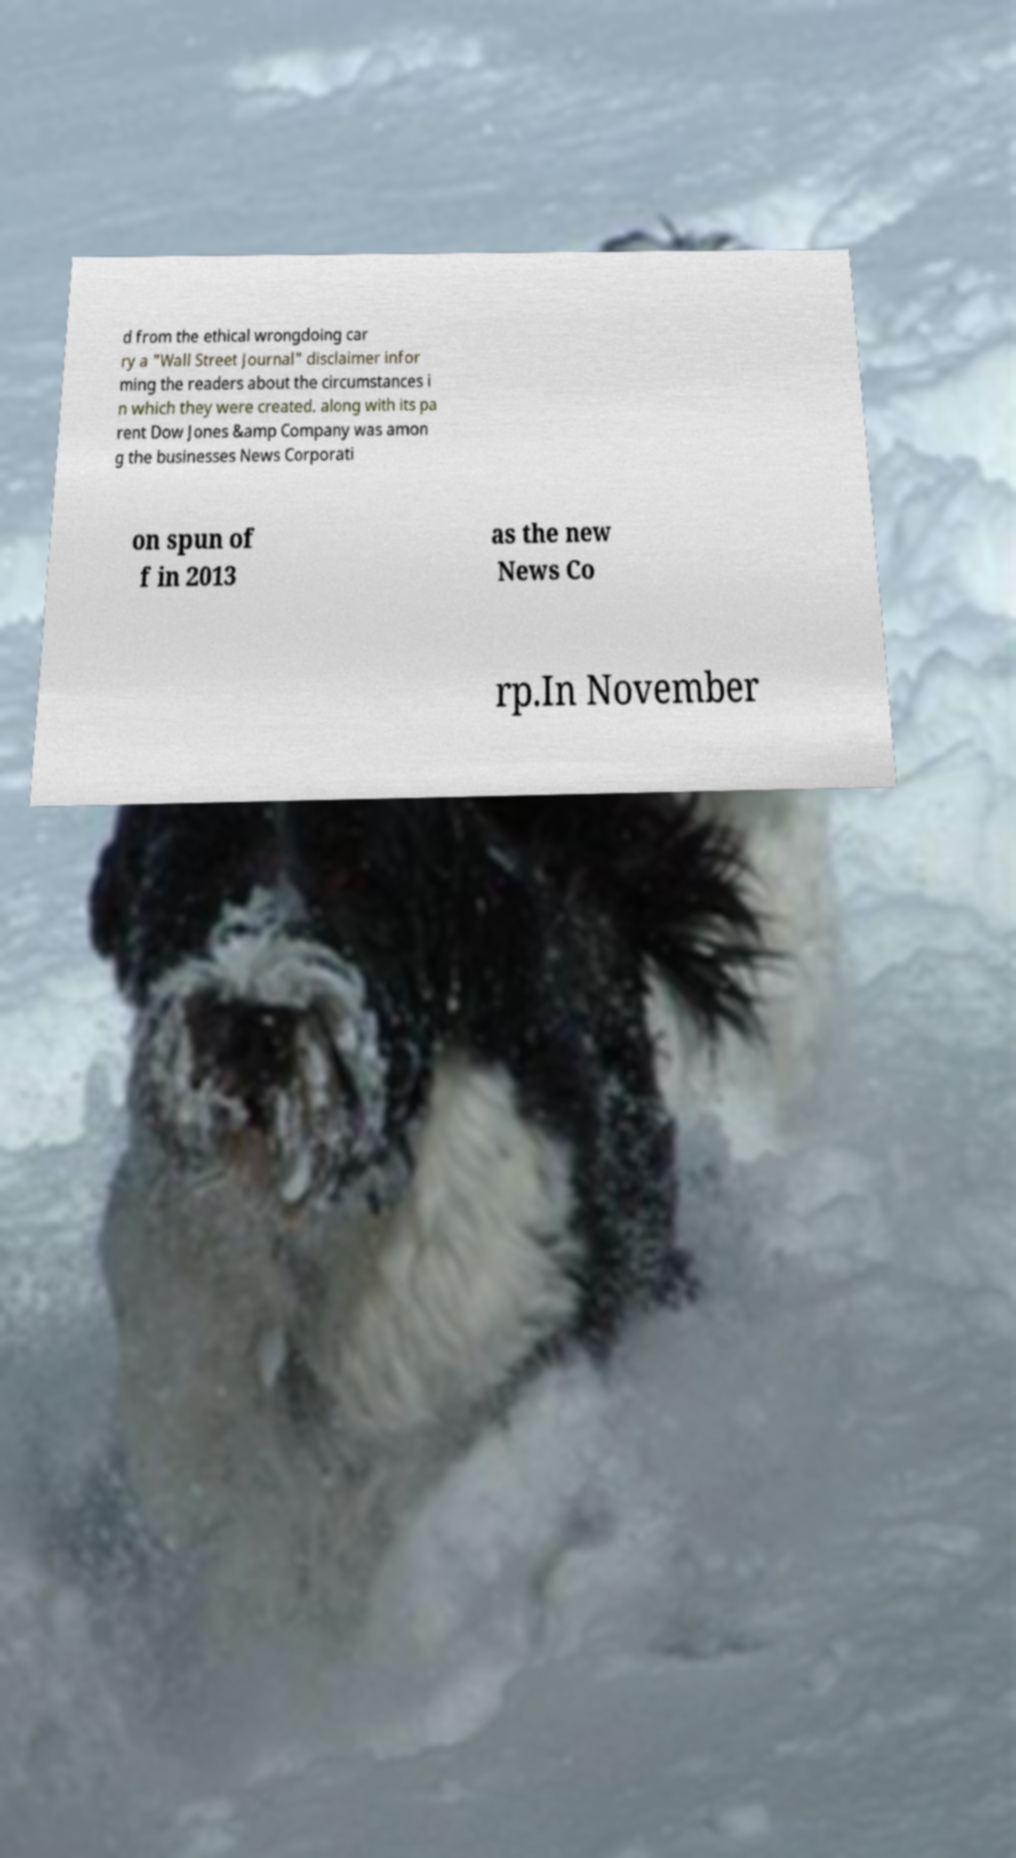Please identify and transcribe the text found in this image. d from the ethical wrongdoing car ry a "Wall Street Journal" disclaimer infor ming the readers about the circumstances i n which they were created. along with its pa rent Dow Jones &amp Company was amon g the businesses News Corporati on spun of f in 2013 as the new News Co rp.In November 